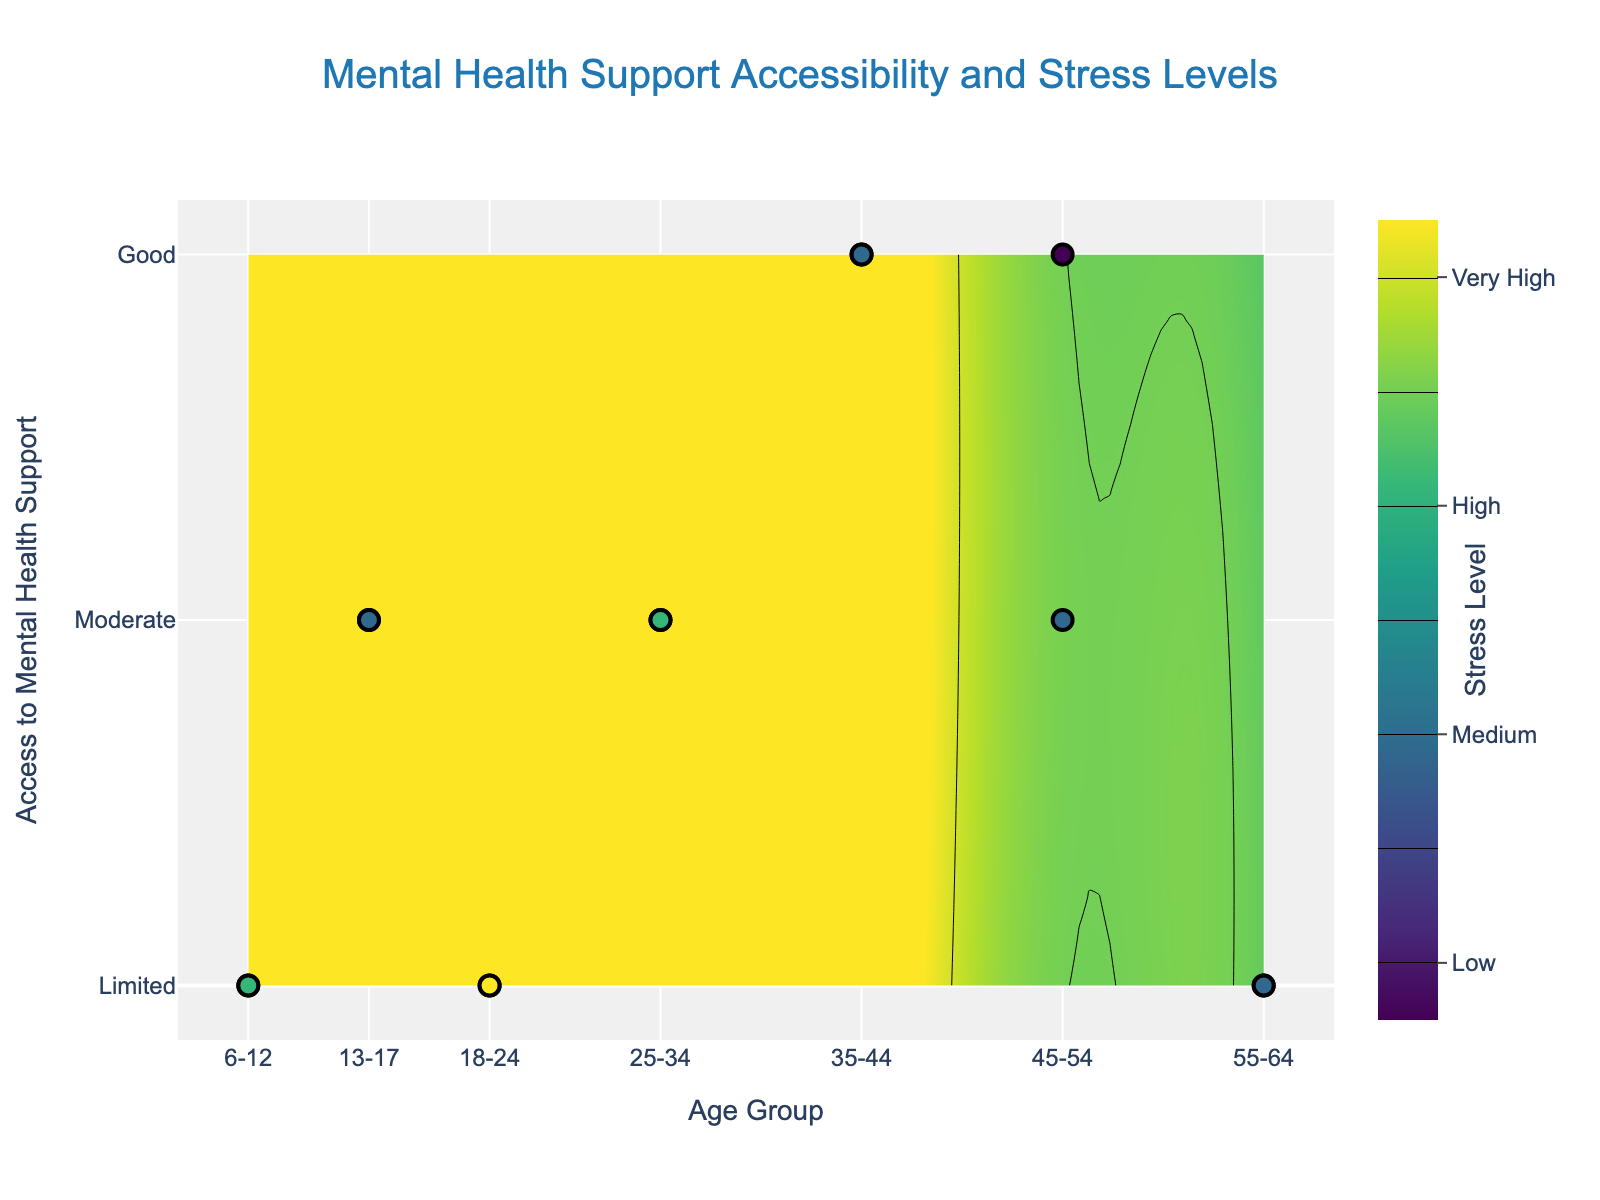What is the title of the contour plot? The title is usually found at the top of the contour plot. In this case, it is displayed in a prominent position with larger font size.
Answer: Mental Health Support Accessibility and Stress Levels What are the color scales representing in the contour plot? The color scale is shown in the colorbar on the right side of the plot. It indicates different levels of stress, ranging from low to very high using different colors.
Answer: Stress levels Besides contour areas, what additional visual elements represent individual data points? Individual data points are represented as scatter points on the plot. These points are distinguished by their color and position, indicating their corresponding age group, mental health support accessibility, and stress levels.
Answer: Scatter points Which age group shows the highest stress levels, and what is their access to mental health support? By observing the color intensities and the scatter points' positions, we can identify the age group with the highest stress levels and check the corresponding y-axis value for their access to mental health support. The darkest areas and the highest "scatter" values indicate the highest levels.
Answer: 18-24, Limited Compare the stress levels for age groups 6-12 and 35-44. Which group experiences higher stress levels? By comparing the contour colors and positions of the scatter points between these two age groups, we can determine which age group experiences higher stress levels. The group with darker shades (higher positions) on the stress scale has higher stress levels.
Answer: 6-12 What is the relationship between access to mental health support and stress levels in the refugee community? By observing the general trend in the contour plot, especially the correlation between the y-axis (access to mental health support) and the color intensity (stress levels), we can identify the trend. Generally, areas with limited access have higher stress levels while good access areas have lower stress.
Answer: Limited access correlates with higher stress levels Identify the gender of the data point with moderate access to mental health support and medium stress levels in the 45-54 age group. By looking at the scatter points within the respective age group and checking the hover information (not visible in the static image but in interactive plots), we identify the gender of the selected data point based on its tooltip information.
Answer: Female How does the distribution of stress levels change across different age groups with moderate access to mental health support? By examining the contour areas and scatter points within the y-axis value corresponding to moderate access, we can observe changes in the stress levels. Compare the color intensities and ranges within those areas.
Answer: Higher in middle age groups (25-34, 35-44) Determine the average stress level for data points with good access to mental health support. Locate the scatter points along the good access line (y=2). Note down the stress levels indicated by their color values, sum them up and divide by the number of data points. This requires some approximation based on contour colors.
Answer: Medium to Low 